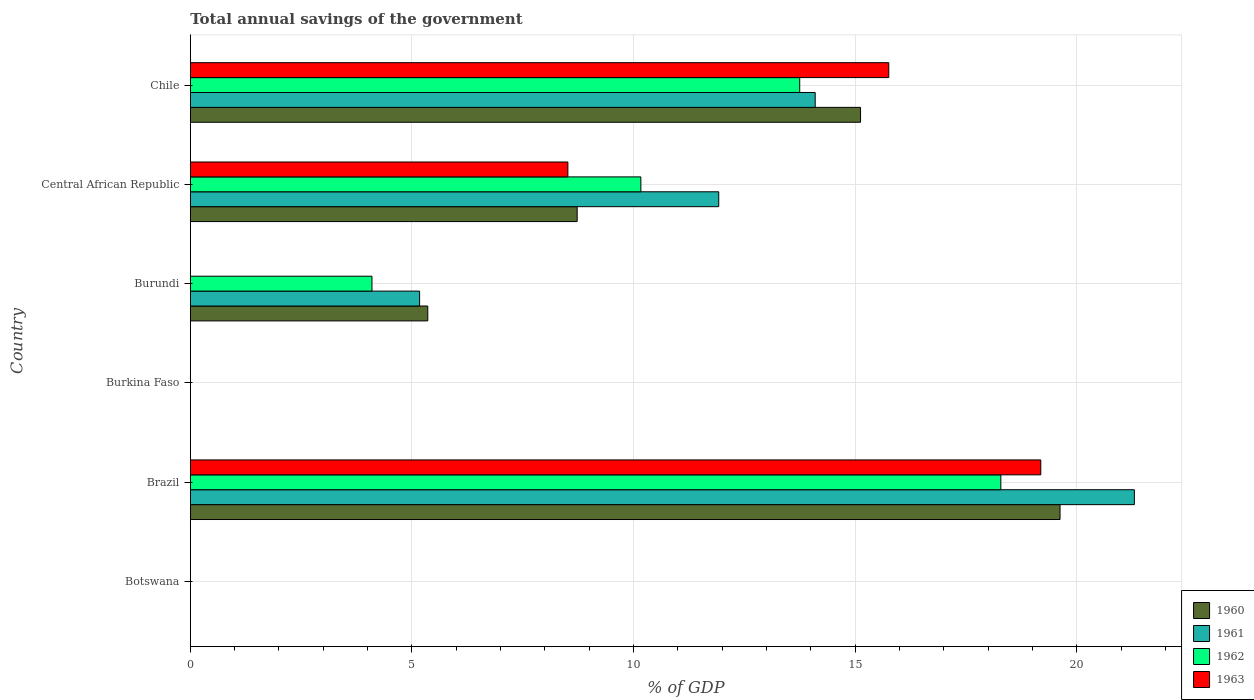How many different coloured bars are there?
Your answer should be very brief. 4. Are the number of bars per tick equal to the number of legend labels?
Offer a terse response. No. How many bars are there on the 3rd tick from the top?
Your answer should be compact. 3. How many bars are there on the 3rd tick from the bottom?
Give a very brief answer. 0. What is the label of the 2nd group of bars from the top?
Your response must be concise. Central African Republic. Across all countries, what is the maximum total annual savings of the government in 1962?
Keep it short and to the point. 18.28. Across all countries, what is the minimum total annual savings of the government in 1963?
Give a very brief answer. 0. What is the total total annual savings of the government in 1960 in the graph?
Make the answer very short. 48.82. What is the difference between the total annual savings of the government in 1961 in Brazil and that in Central African Republic?
Offer a terse response. 9.38. What is the difference between the total annual savings of the government in 1962 in Burundi and the total annual savings of the government in 1963 in Burkina Faso?
Offer a terse response. 4.1. What is the average total annual savings of the government in 1960 per country?
Offer a terse response. 8.14. What is the difference between the total annual savings of the government in 1960 and total annual savings of the government in 1961 in Burundi?
Provide a short and direct response. 0.18. What is the ratio of the total annual savings of the government in 1960 in Brazil to that in Chile?
Make the answer very short. 1.3. Is the total annual savings of the government in 1960 in Brazil less than that in Burundi?
Offer a terse response. No. Is the difference between the total annual savings of the government in 1960 in Central African Republic and Chile greater than the difference between the total annual savings of the government in 1961 in Central African Republic and Chile?
Ensure brevity in your answer.  No. What is the difference between the highest and the second highest total annual savings of the government in 1960?
Your answer should be very brief. 4.5. What is the difference between the highest and the lowest total annual savings of the government in 1960?
Offer a terse response. 19.62. In how many countries, is the total annual savings of the government in 1961 greater than the average total annual savings of the government in 1961 taken over all countries?
Provide a short and direct response. 3. Is the sum of the total annual savings of the government in 1961 in Brazil and Central African Republic greater than the maximum total annual savings of the government in 1963 across all countries?
Your response must be concise. Yes. Is it the case that in every country, the sum of the total annual savings of the government in 1960 and total annual savings of the government in 1961 is greater than the sum of total annual savings of the government in 1962 and total annual savings of the government in 1963?
Your response must be concise. No. Is it the case that in every country, the sum of the total annual savings of the government in 1961 and total annual savings of the government in 1963 is greater than the total annual savings of the government in 1962?
Make the answer very short. No. How many countries are there in the graph?
Keep it short and to the point. 6. What is the difference between two consecutive major ticks on the X-axis?
Make the answer very short. 5. Does the graph contain any zero values?
Keep it short and to the point. Yes. Where does the legend appear in the graph?
Your answer should be very brief. Bottom right. How many legend labels are there?
Keep it short and to the point. 4. What is the title of the graph?
Make the answer very short. Total annual savings of the government. Does "2007" appear as one of the legend labels in the graph?
Provide a short and direct response. No. What is the label or title of the X-axis?
Offer a very short reply. % of GDP. What is the % of GDP in 1960 in Botswana?
Provide a short and direct response. 0. What is the % of GDP in 1962 in Botswana?
Make the answer very short. 0. What is the % of GDP of 1960 in Brazil?
Keep it short and to the point. 19.62. What is the % of GDP of 1961 in Brazil?
Make the answer very short. 21.3. What is the % of GDP in 1962 in Brazil?
Ensure brevity in your answer.  18.28. What is the % of GDP in 1963 in Brazil?
Offer a very short reply. 19.19. What is the % of GDP in 1960 in Burkina Faso?
Offer a terse response. 0. What is the % of GDP of 1961 in Burkina Faso?
Provide a short and direct response. 0. What is the % of GDP of 1962 in Burkina Faso?
Your answer should be compact. 0. What is the % of GDP in 1960 in Burundi?
Give a very brief answer. 5.36. What is the % of GDP of 1961 in Burundi?
Your answer should be compact. 5.17. What is the % of GDP of 1962 in Burundi?
Your response must be concise. 4.1. What is the % of GDP in 1963 in Burundi?
Your response must be concise. 0. What is the % of GDP in 1960 in Central African Republic?
Your answer should be compact. 8.73. What is the % of GDP in 1961 in Central African Republic?
Give a very brief answer. 11.92. What is the % of GDP of 1962 in Central African Republic?
Keep it short and to the point. 10.16. What is the % of GDP in 1963 in Central African Republic?
Give a very brief answer. 8.52. What is the % of GDP of 1960 in Chile?
Give a very brief answer. 15.12. What is the % of GDP in 1961 in Chile?
Give a very brief answer. 14.1. What is the % of GDP of 1962 in Chile?
Offer a terse response. 13.75. What is the % of GDP in 1963 in Chile?
Keep it short and to the point. 15.76. Across all countries, what is the maximum % of GDP of 1960?
Keep it short and to the point. 19.62. Across all countries, what is the maximum % of GDP in 1961?
Your answer should be compact. 21.3. Across all countries, what is the maximum % of GDP of 1962?
Provide a short and direct response. 18.28. Across all countries, what is the maximum % of GDP of 1963?
Provide a short and direct response. 19.19. Across all countries, what is the minimum % of GDP in 1962?
Your answer should be compact. 0. Across all countries, what is the minimum % of GDP in 1963?
Your answer should be very brief. 0. What is the total % of GDP in 1960 in the graph?
Keep it short and to the point. 48.82. What is the total % of GDP in 1961 in the graph?
Offer a very short reply. 52.49. What is the total % of GDP of 1962 in the graph?
Make the answer very short. 46.29. What is the total % of GDP of 1963 in the graph?
Your response must be concise. 43.46. What is the difference between the % of GDP of 1960 in Brazil and that in Burundi?
Your answer should be very brief. 14.26. What is the difference between the % of GDP in 1961 in Brazil and that in Burundi?
Provide a succinct answer. 16.12. What is the difference between the % of GDP of 1962 in Brazil and that in Burundi?
Keep it short and to the point. 14.19. What is the difference between the % of GDP in 1960 in Brazil and that in Central African Republic?
Make the answer very short. 10.89. What is the difference between the % of GDP of 1961 in Brazil and that in Central African Republic?
Your answer should be compact. 9.38. What is the difference between the % of GDP of 1962 in Brazil and that in Central African Republic?
Your response must be concise. 8.12. What is the difference between the % of GDP of 1963 in Brazil and that in Central African Republic?
Your answer should be very brief. 10.67. What is the difference between the % of GDP in 1960 in Brazil and that in Chile?
Your answer should be compact. 4.5. What is the difference between the % of GDP in 1961 in Brazil and that in Chile?
Offer a terse response. 7.2. What is the difference between the % of GDP of 1962 in Brazil and that in Chile?
Ensure brevity in your answer.  4.54. What is the difference between the % of GDP of 1963 in Brazil and that in Chile?
Offer a very short reply. 3.43. What is the difference between the % of GDP in 1960 in Burundi and that in Central African Republic?
Ensure brevity in your answer.  -3.37. What is the difference between the % of GDP in 1961 in Burundi and that in Central African Republic?
Your answer should be very brief. -6.75. What is the difference between the % of GDP of 1962 in Burundi and that in Central African Republic?
Your response must be concise. -6.07. What is the difference between the % of GDP of 1960 in Burundi and that in Chile?
Make the answer very short. -9.76. What is the difference between the % of GDP of 1961 in Burundi and that in Chile?
Offer a terse response. -8.92. What is the difference between the % of GDP in 1962 in Burundi and that in Chile?
Your answer should be compact. -9.65. What is the difference between the % of GDP in 1960 in Central African Republic and that in Chile?
Provide a succinct answer. -6.39. What is the difference between the % of GDP of 1961 in Central African Republic and that in Chile?
Provide a succinct answer. -2.18. What is the difference between the % of GDP in 1962 in Central African Republic and that in Chile?
Your answer should be very brief. -3.58. What is the difference between the % of GDP in 1963 in Central African Republic and that in Chile?
Give a very brief answer. -7.24. What is the difference between the % of GDP of 1960 in Brazil and the % of GDP of 1961 in Burundi?
Offer a terse response. 14.45. What is the difference between the % of GDP of 1960 in Brazil and the % of GDP of 1962 in Burundi?
Your answer should be very brief. 15.52. What is the difference between the % of GDP of 1961 in Brazil and the % of GDP of 1962 in Burundi?
Provide a short and direct response. 17.2. What is the difference between the % of GDP of 1960 in Brazil and the % of GDP of 1961 in Central African Republic?
Make the answer very short. 7.7. What is the difference between the % of GDP of 1960 in Brazil and the % of GDP of 1962 in Central African Republic?
Your answer should be very brief. 9.46. What is the difference between the % of GDP in 1960 in Brazil and the % of GDP in 1963 in Central African Republic?
Offer a terse response. 11.1. What is the difference between the % of GDP in 1961 in Brazil and the % of GDP in 1962 in Central African Republic?
Provide a succinct answer. 11.13. What is the difference between the % of GDP in 1961 in Brazil and the % of GDP in 1963 in Central African Republic?
Keep it short and to the point. 12.78. What is the difference between the % of GDP of 1962 in Brazil and the % of GDP of 1963 in Central African Republic?
Your response must be concise. 9.77. What is the difference between the % of GDP of 1960 in Brazil and the % of GDP of 1961 in Chile?
Provide a succinct answer. 5.52. What is the difference between the % of GDP in 1960 in Brazil and the % of GDP in 1962 in Chile?
Offer a very short reply. 5.87. What is the difference between the % of GDP of 1960 in Brazil and the % of GDP of 1963 in Chile?
Keep it short and to the point. 3.86. What is the difference between the % of GDP in 1961 in Brazil and the % of GDP in 1962 in Chile?
Your response must be concise. 7.55. What is the difference between the % of GDP of 1961 in Brazil and the % of GDP of 1963 in Chile?
Your answer should be compact. 5.54. What is the difference between the % of GDP in 1962 in Brazil and the % of GDP in 1963 in Chile?
Make the answer very short. 2.53. What is the difference between the % of GDP in 1960 in Burundi and the % of GDP in 1961 in Central African Republic?
Offer a terse response. -6.56. What is the difference between the % of GDP in 1960 in Burundi and the % of GDP in 1962 in Central African Republic?
Your answer should be very brief. -4.81. What is the difference between the % of GDP of 1960 in Burundi and the % of GDP of 1963 in Central African Republic?
Make the answer very short. -3.16. What is the difference between the % of GDP in 1961 in Burundi and the % of GDP in 1962 in Central African Republic?
Your response must be concise. -4.99. What is the difference between the % of GDP of 1961 in Burundi and the % of GDP of 1963 in Central African Republic?
Offer a very short reply. -3.34. What is the difference between the % of GDP of 1962 in Burundi and the % of GDP of 1963 in Central African Republic?
Your answer should be compact. -4.42. What is the difference between the % of GDP in 1960 in Burundi and the % of GDP in 1961 in Chile?
Ensure brevity in your answer.  -8.74. What is the difference between the % of GDP of 1960 in Burundi and the % of GDP of 1962 in Chile?
Offer a very short reply. -8.39. What is the difference between the % of GDP of 1960 in Burundi and the % of GDP of 1963 in Chile?
Make the answer very short. -10.4. What is the difference between the % of GDP in 1961 in Burundi and the % of GDP in 1962 in Chile?
Offer a very short reply. -8.58. What is the difference between the % of GDP in 1961 in Burundi and the % of GDP in 1963 in Chile?
Keep it short and to the point. -10.58. What is the difference between the % of GDP of 1962 in Burundi and the % of GDP of 1963 in Chile?
Provide a succinct answer. -11.66. What is the difference between the % of GDP in 1960 in Central African Republic and the % of GDP in 1961 in Chile?
Make the answer very short. -5.37. What is the difference between the % of GDP of 1960 in Central African Republic and the % of GDP of 1962 in Chile?
Provide a short and direct response. -5.02. What is the difference between the % of GDP of 1960 in Central African Republic and the % of GDP of 1963 in Chile?
Ensure brevity in your answer.  -7.03. What is the difference between the % of GDP in 1961 in Central African Republic and the % of GDP in 1962 in Chile?
Your response must be concise. -1.83. What is the difference between the % of GDP in 1961 in Central African Republic and the % of GDP in 1963 in Chile?
Provide a succinct answer. -3.84. What is the difference between the % of GDP of 1962 in Central African Republic and the % of GDP of 1963 in Chile?
Make the answer very short. -5.59. What is the average % of GDP of 1960 per country?
Make the answer very short. 8.14. What is the average % of GDP of 1961 per country?
Your answer should be very brief. 8.75. What is the average % of GDP in 1962 per country?
Ensure brevity in your answer.  7.72. What is the average % of GDP in 1963 per country?
Your response must be concise. 7.24. What is the difference between the % of GDP of 1960 and % of GDP of 1961 in Brazil?
Ensure brevity in your answer.  -1.68. What is the difference between the % of GDP of 1960 and % of GDP of 1962 in Brazil?
Your answer should be compact. 1.34. What is the difference between the % of GDP in 1960 and % of GDP in 1963 in Brazil?
Provide a short and direct response. 0.43. What is the difference between the % of GDP of 1961 and % of GDP of 1962 in Brazil?
Ensure brevity in your answer.  3.01. What is the difference between the % of GDP in 1961 and % of GDP in 1963 in Brazil?
Keep it short and to the point. 2.11. What is the difference between the % of GDP of 1962 and % of GDP of 1963 in Brazil?
Keep it short and to the point. -0.9. What is the difference between the % of GDP in 1960 and % of GDP in 1961 in Burundi?
Provide a succinct answer. 0.18. What is the difference between the % of GDP in 1960 and % of GDP in 1962 in Burundi?
Your answer should be compact. 1.26. What is the difference between the % of GDP of 1961 and % of GDP of 1962 in Burundi?
Your answer should be compact. 1.07. What is the difference between the % of GDP of 1960 and % of GDP of 1961 in Central African Republic?
Provide a short and direct response. -3.19. What is the difference between the % of GDP in 1960 and % of GDP in 1962 in Central African Republic?
Offer a very short reply. -1.44. What is the difference between the % of GDP in 1960 and % of GDP in 1963 in Central African Republic?
Give a very brief answer. 0.21. What is the difference between the % of GDP of 1961 and % of GDP of 1962 in Central African Republic?
Provide a succinct answer. 1.76. What is the difference between the % of GDP in 1961 and % of GDP in 1963 in Central African Republic?
Offer a very short reply. 3.4. What is the difference between the % of GDP of 1962 and % of GDP of 1963 in Central African Republic?
Provide a succinct answer. 1.65. What is the difference between the % of GDP of 1960 and % of GDP of 1961 in Chile?
Your answer should be very brief. 1.02. What is the difference between the % of GDP in 1960 and % of GDP in 1962 in Chile?
Provide a succinct answer. 1.37. What is the difference between the % of GDP of 1960 and % of GDP of 1963 in Chile?
Offer a terse response. -0.64. What is the difference between the % of GDP in 1961 and % of GDP in 1962 in Chile?
Your answer should be compact. 0.35. What is the difference between the % of GDP in 1961 and % of GDP in 1963 in Chile?
Provide a succinct answer. -1.66. What is the difference between the % of GDP of 1962 and % of GDP of 1963 in Chile?
Provide a short and direct response. -2.01. What is the ratio of the % of GDP in 1960 in Brazil to that in Burundi?
Ensure brevity in your answer.  3.66. What is the ratio of the % of GDP in 1961 in Brazil to that in Burundi?
Offer a terse response. 4.12. What is the ratio of the % of GDP in 1962 in Brazil to that in Burundi?
Ensure brevity in your answer.  4.46. What is the ratio of the % of GDP of 1960 in Brazil to that in Central African Republic?
Your answer should be compact. 2.25. What is the ratio of the % of GDP in 1961 in Brazil to that in Central African Republic?
Your answer should be very brief. 1.79. What is the ratio of the % of GDP of 1962 in Brazil to that in Central African Republic?
Make the answer very short. 1.8. What is the ratio of the % of GDP in 1963 in Brazil to that in Central African Republic?
Offer a very short reply. 2.25. What is the ratio of the % of GDP of 1960 in Brazil to that in Chile?
Make the answer very short. 1.3. What is the ratio of the % of GDP in 1961 in Brazil to that in Chile?
Ensure brevity in your answer.  1.51. What is the ratio of the % of GDP of 1962 in Brazil to that in Chile?
Your answer should be compact. 1.33. What is the ratio of the % of GDP of 1963 in Brazil to that in Chile?
Offer a very short reply. 1.22. What is the ratio of the % of GDP of 1960 in Burundi to that in Central African Republic?
Your response must be concise. 0.61. What is the ratio of the % of GDP in 1961 in Burundi to that in Central African Republic?
Ensure brevity in your answer.  0.43. What is the ratio of the % of GDP in 1962 in Burundi to that in Central African Republic?
Offer a very short reply. 0.4. What is the ratio of the % of GDP of 1960 in Burundi to that in Chile?
Give a very brief answer. 0.35. What is the ratio of the % of GDP in 1961 in Burundi to that in Chile?
Offer a terse response. 0.37. What is the ratio of the % of GDP in 1962 in Burundi to that in Chile?
Give a very brief answer. 0.3. What is the ratio of the % of GDP in 1960 in Central African Republic to that in Chile?
Give a very brief answer. 0.58. What is the ratio of the % of GDP in 1961 in Central African Republic to that in Chile?
Offer a very short reply. 0.85. What is the ratio of the % of GDP in 1962 in Central African Republic to that in Chile?
Provide a succinct answer. 0.74. What is the ratio of the % of GDP in 1963 in Central African Republic to that in Chile?
Your answer should be compact. 0.54. What is the difference between the highest and the second highest % of GDP in 1960?
Your answer should be compact. 4.5. What is the difference between the highest and the second highest % of GDP of 1961?
Provide a short and direct response. 7.2. What is the difference between the highest and the second highest % of GDP of 1962?
Your response must be concise. 4.54. What is the difference between the highest and the second highest % of GDP in 1963?
Offer a terse response. 3.43. What is the difference between the highest and the lowest % of GDP in 1960?
Provide a succinct answer. 19.62. What is the difference between the highest and the lowest % of GDP of 1961?
Provide a short and direct response. 21.3. What is the difference between the highest and the lowest % of GDP of 1962?
Make the answer very short. 18.28. What is the difference between the highest and the lowest % of GDP in 1963?
Your answer should be very brief. 19.19. 